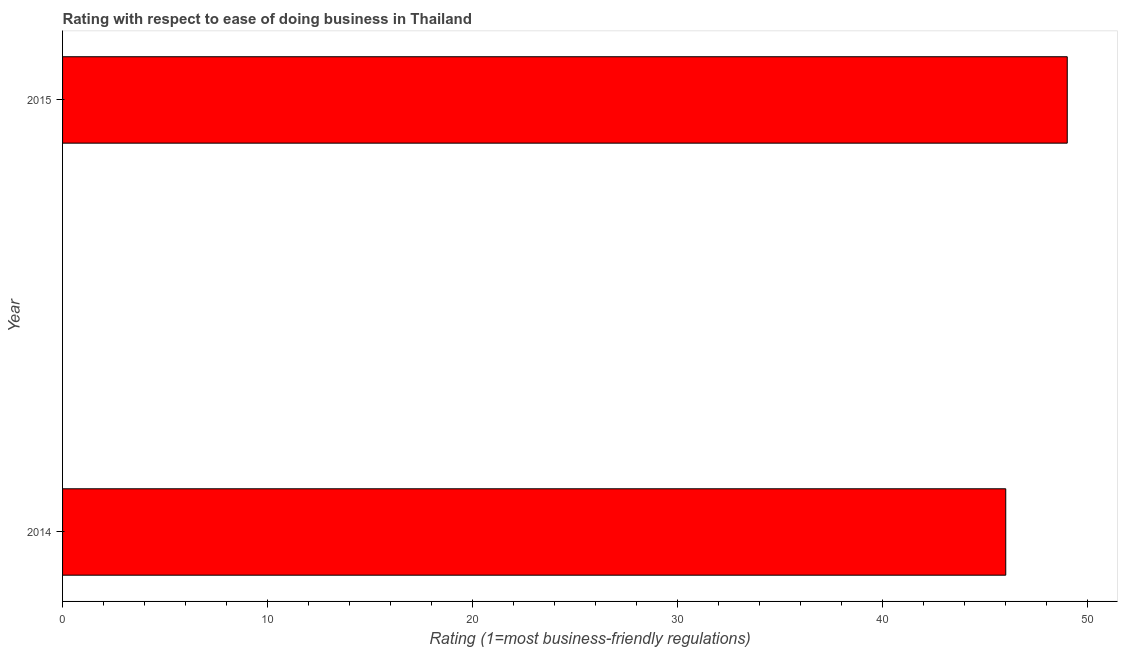Does the graph contain grids?
Keep it short and to the point. No. What is the title of the graph?
Offer a terse response. Rating with respect to ease of doing business in Thailand. What is the label or title of the X-axis?
Your response must be concise. Rating (1=most business-friendly regulations). What is the label or title of the Y-axis?
Provide a short and direct response. Year. What is the ease of doing business index in 2015?
Offer a terse response. 49. Across all years, what is the minimum ease of doing business index?
Make the answer very short. 46. In which year was the ease of doing business index maximum?
Make the answer very short. 2015. In which year was the ease of doing business index minimum?
Offer a very short reply. 2014. What is the difference between the ease of doing business index in 2014 and 2015?
Offer a terse response. -3. What is the median ease of doing business index?
Keep it short and to the point. 47.5. What is the ratio of the ease of doing business index in 2014 to that in 2015?
Your response must be concise. 0.94. In how many years, is the ease of doing business index greater than the average ease of doing business index taken over all years?
Your answer should be compact. 1. How many years are there in the graph?
Offer a terse response. 2. What is the difference between two consecutive major ticks on the X-axis?
Provide a short and direct response. 10. What is the Rating (1=most business-friendly regulations) of 2014?
Your response must be concise. 46. What is the difference between the Rating (1=most business-friendly regulations) in 2014 and 2015?
Give a very brief answer. -3. What is the ratio of the Rating (1=most business-friendly regulations) in 2014 to that in 2015?
Provide a short and direct response. 0.94. 